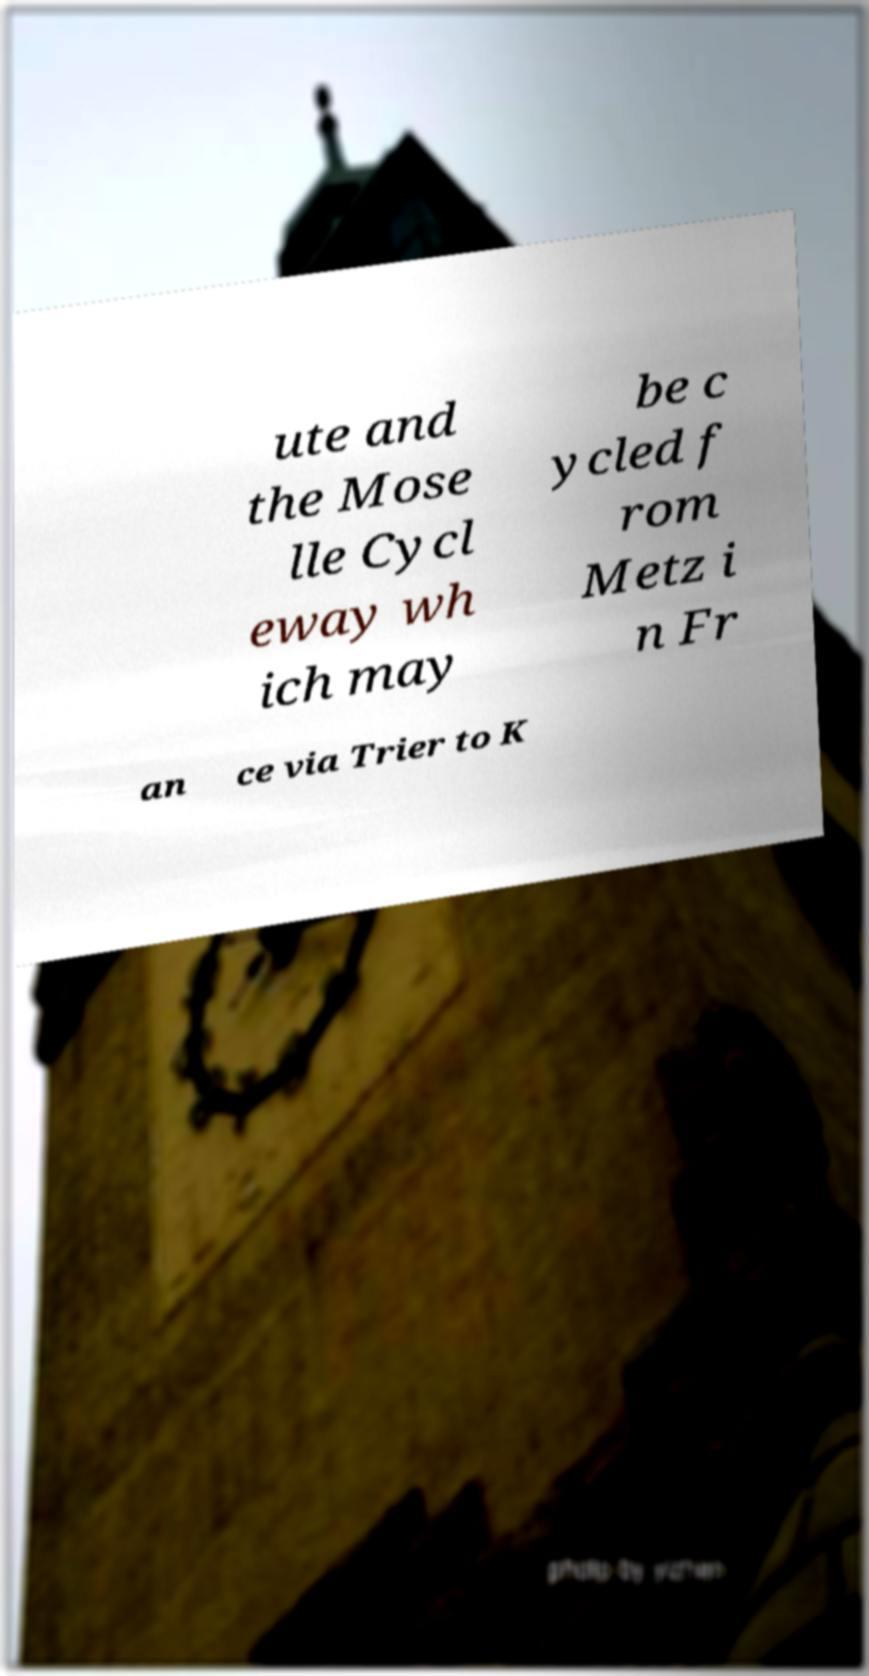Can you read and provide the text displayed in the image?This photo seems to have some interesting text. Can you extract and type it out for me? ute and the Mose lle Cycl eway wh ich may be c ycled f rom Metz i n Fr an ce via Trier to K 